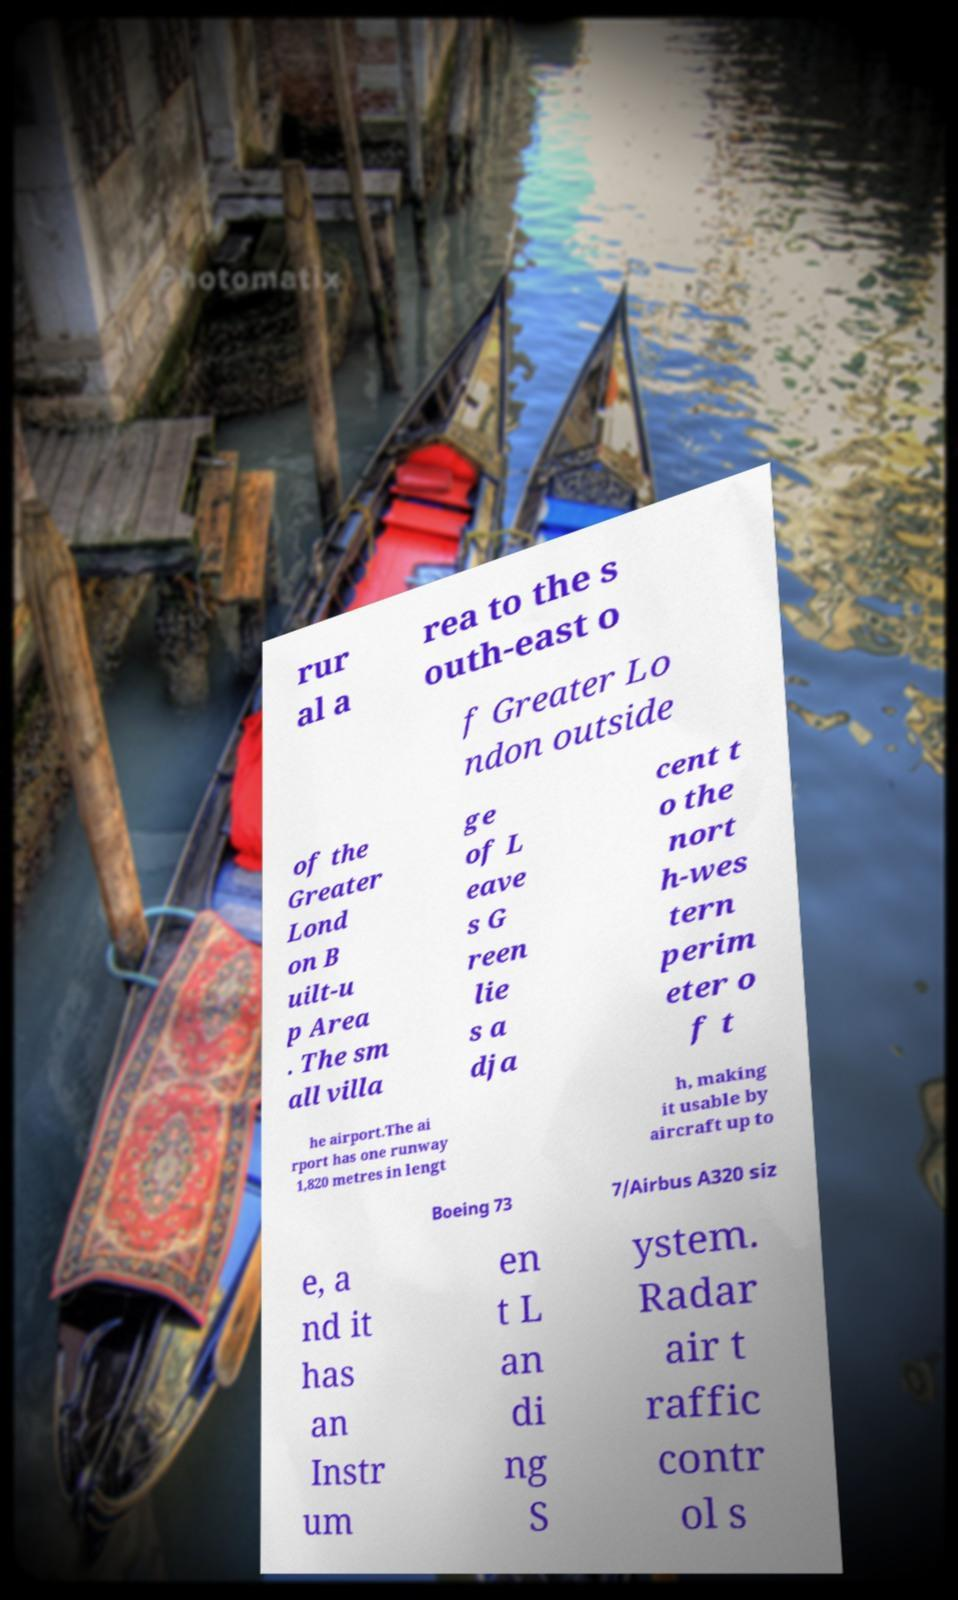I need the written content from this picture converted into text. Can you do that? rur al a rea to the s outh-east o f Greater Lo ndon outside of the Greater Lond on B uilt-u p Area . The sm all villa ge of L eave s G reen lie s a dja cent t o the nort h-wes tern perim eter o f t he airport.The ai rport has one runway 1,820 metres in lengt h, making it usable by aircraft up to Boeing 73 7/Airbus A320 siz e, a nd it has an Instr um en t L an di ng S ystem. Radar air t raffic contr ol s 